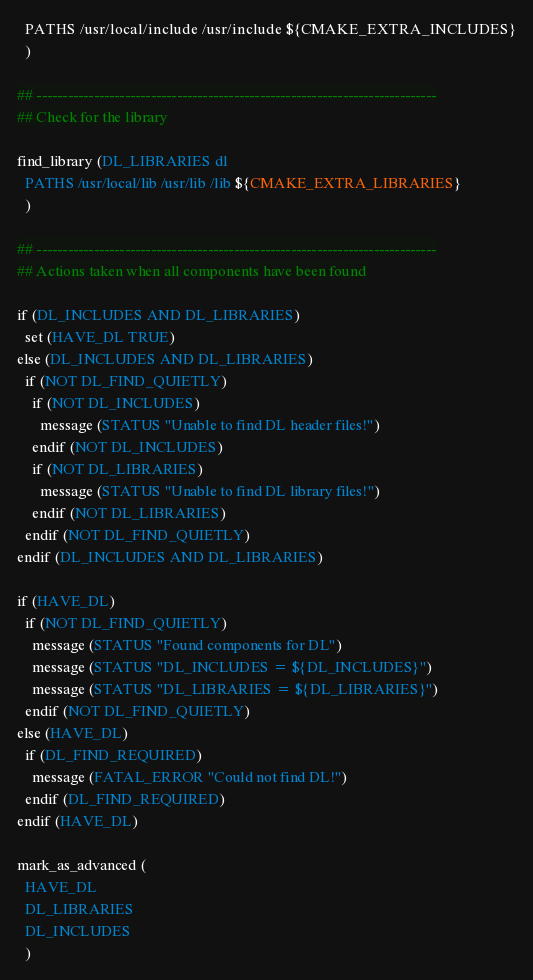Convert code to text. <code><loc_0><loc_0><loc_500><loc_500><_CMake_>  PATHS /usr/local/include /usr/include ${CMAKE_EXTRA_INCLUDES}
  )

## -----------------------------------------------------------------------------
## Check for the library

find_library (DL_LIBRARIES dl
  PATHS /usr/local/lib /usr/lib /lib ${CMAKE_EXTRA_LIBRARIES}
  )

## -----------------------------------------------------------------------------
## Actions taken when all components have been found

if (DL_INCLUDES AND DL_LIBRARIES)
  set (HAVE_DL TRUE)
else (DL_INCLUDES AND DL_LIBRARIES)
  if (NOT DL_FIND_QUIETLY)
    if (NOT DL_INCLUDES)
      message (STATUS "Unable to find DL header files!")
    endif (NOT DL_INCLUDES)
    if (NOT DL_LIBRARIES)
      message (STATUS "Unable to find DL library files!")
    endif (NOT DL_LIBRARIES)
  endif (NOT DL_FIND_QUIETLY)
endif (DL_INCLUDES AND DL_LIBRARIES)

if (HAVE_DL)
  if (NOT DL_FIND_QUIETLY)
    message (STATUS "Found components for DL")
    message (STATUS "DL_INCLUDES = ${DL_INCLUDES}")
    message (STATUS "DL_LIBRARIES = ${DL_LIBRARIES}")
  endif (NOT DL_FIND_QUIETLY)
else (HAVE_DL)
  if (DL_FIND_REQUIRED)
    message (FATAL_ERROR "Could not find DL!")
  endif (DL_FIND_REQUIRED)
endif (HAVE_DL)

mark_as_advanced (
  HAVE_DL
  DL_LIBRARIES
  DL_INCLUDES
  )</code> 